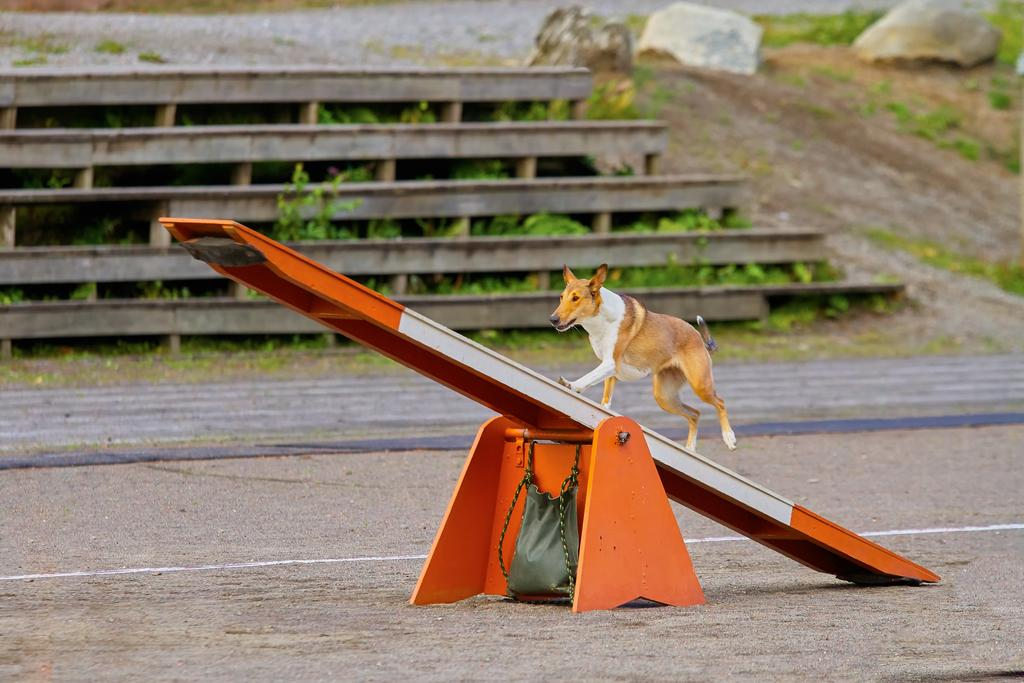What animal can be seen in the image? There is a dog in the image. What is the dog doing in the image? The dog is standing on a see saw. What can be seen in the background of the image? There are iron bars, plants, and rocks in the background of the image. What tax is being applied to the dog in the image? There is no tax being applied to the dog in the image; it is a photograph and not a real-life scenario. 